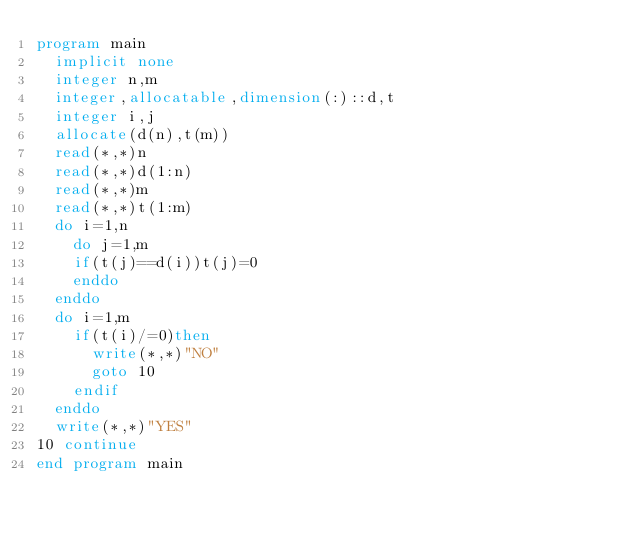Convert code to text. <code><loc_0><loc_0><loc_500><loc_500><_FORTRAN_>program main
	implicit none
	integer n,m
	integer,allocatable,dimension(:)::d,t
	integer i,j
	allocate(d(n),t(m))
	read(*,*)n
	read(*,*)d(1:n)
	read(*,*)m
	read(*,*)t(1:m)
	do i=1,n
		do j=1,m
		if(t(j)==d(i))t(j)=0
		enddo
	enddo
	do i=1,m
		if(t(i)/=0)then
			write(*,*)"NO"
			goto 10
		endif
	enddo
	write(*,*)"YES"
10 continue	
end program main
</code> 